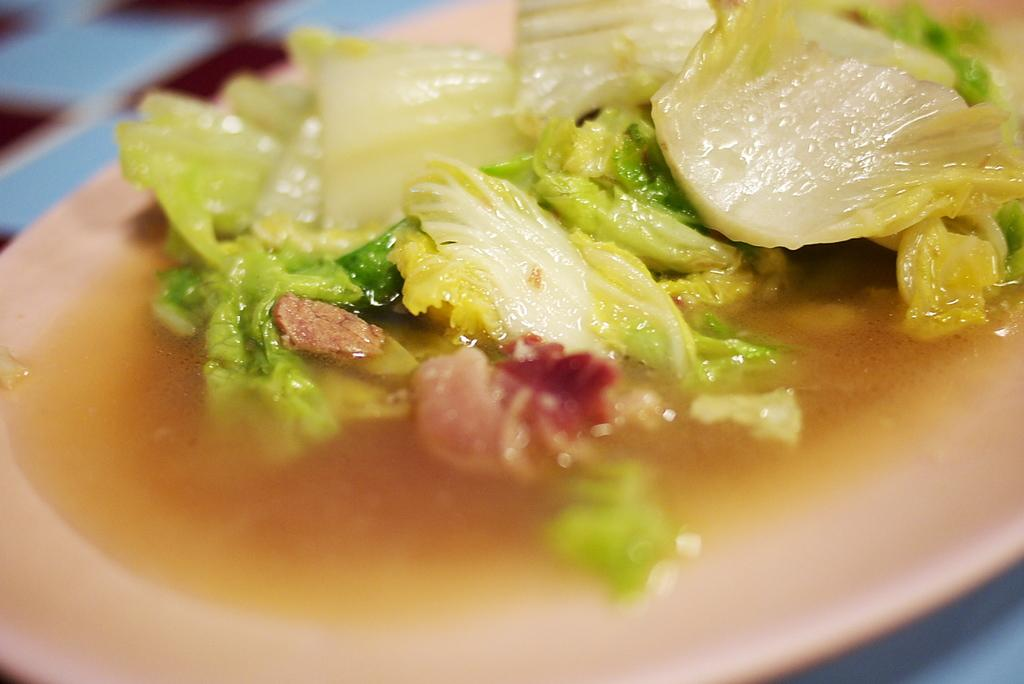What is the main subject of the image? There is a food item on a plate in the image. What type of chalk is being used by the woman in the image? There is no woman or chalk present in the image; it only features a food item on a plate. 